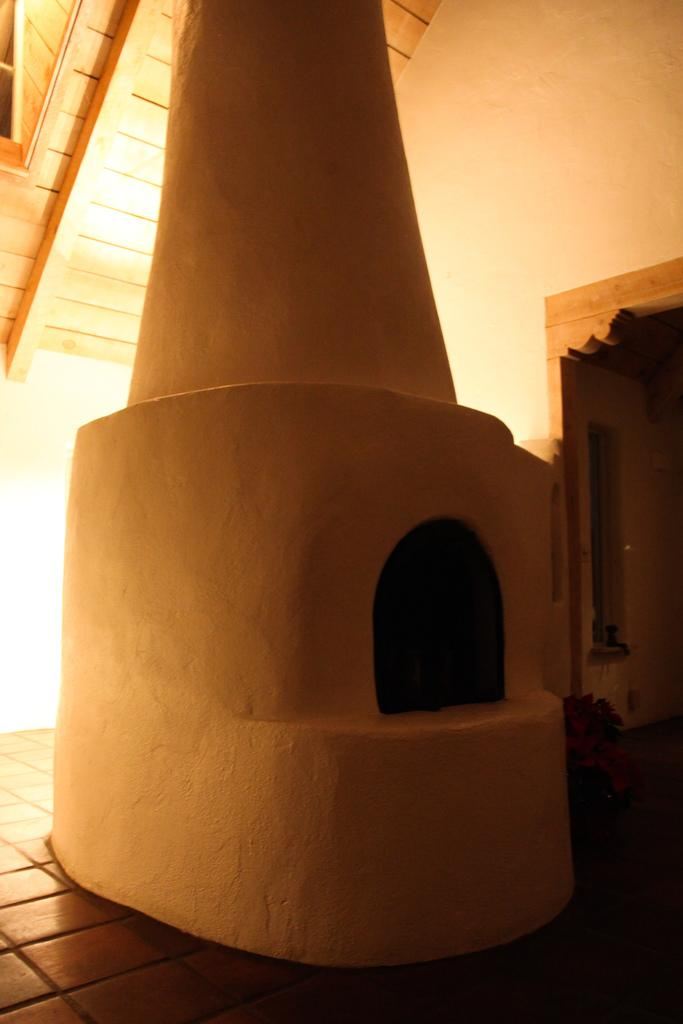What color is the floor in the image? The floor in the image is brown colored. What structure is visible above the room in the image? There is a roof visible in the image. What feature is present for heating purposes in the image? A fireplace is present in the image. What separates the room from the outside in the image? There is a wall in the image. What type of furniture can be seen in the image? Wooden furniture is present in the image. What decorative element is present in the image? There are flowers in the image. What allows natural light to enter the room in the image? A window is visible in the image. What type of button is being pushed by the flowers in the image? There are no buttons present in the image, and the flowers are not interacting with any objects in such a way. How does the attention of the furniture change throughout the day in the image? The furniture does not have the ability to change its attention, as it is an inanimate object. 